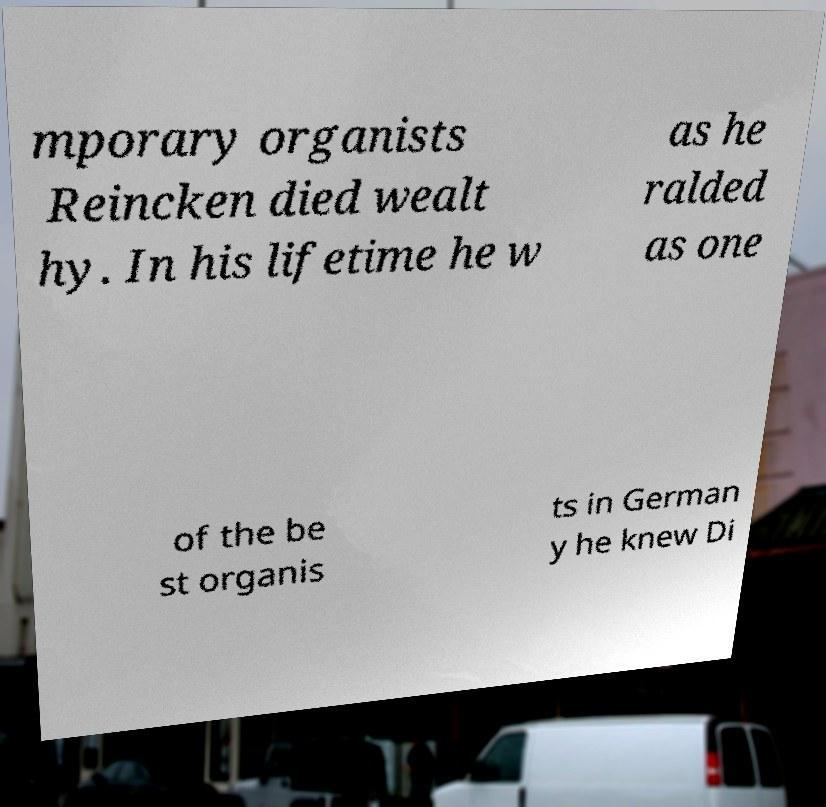Could you assist in decoding the text presented in this image and type it out clearly? mporary organists Reincken died wealt hy. In his lifetime he w as he ralded as one of the be st organis ts in German y he knew Di 